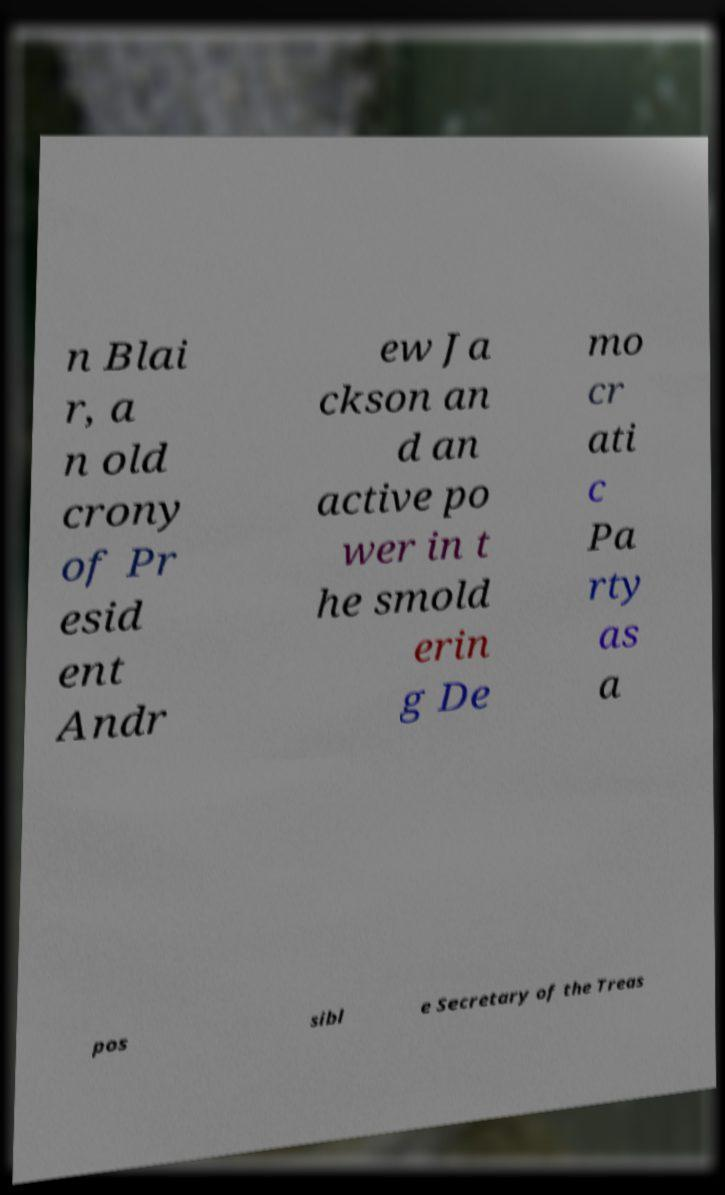For documentation purposes, I need the text within this image transcribed. Could you provide that? n Blai r, a n old crony of Pr esid ent Andr ew Ja ckson an d an active po wer in t he smold erin g De mo cr ati c Pa rty as a pos sibl e Secretary of the Treas 